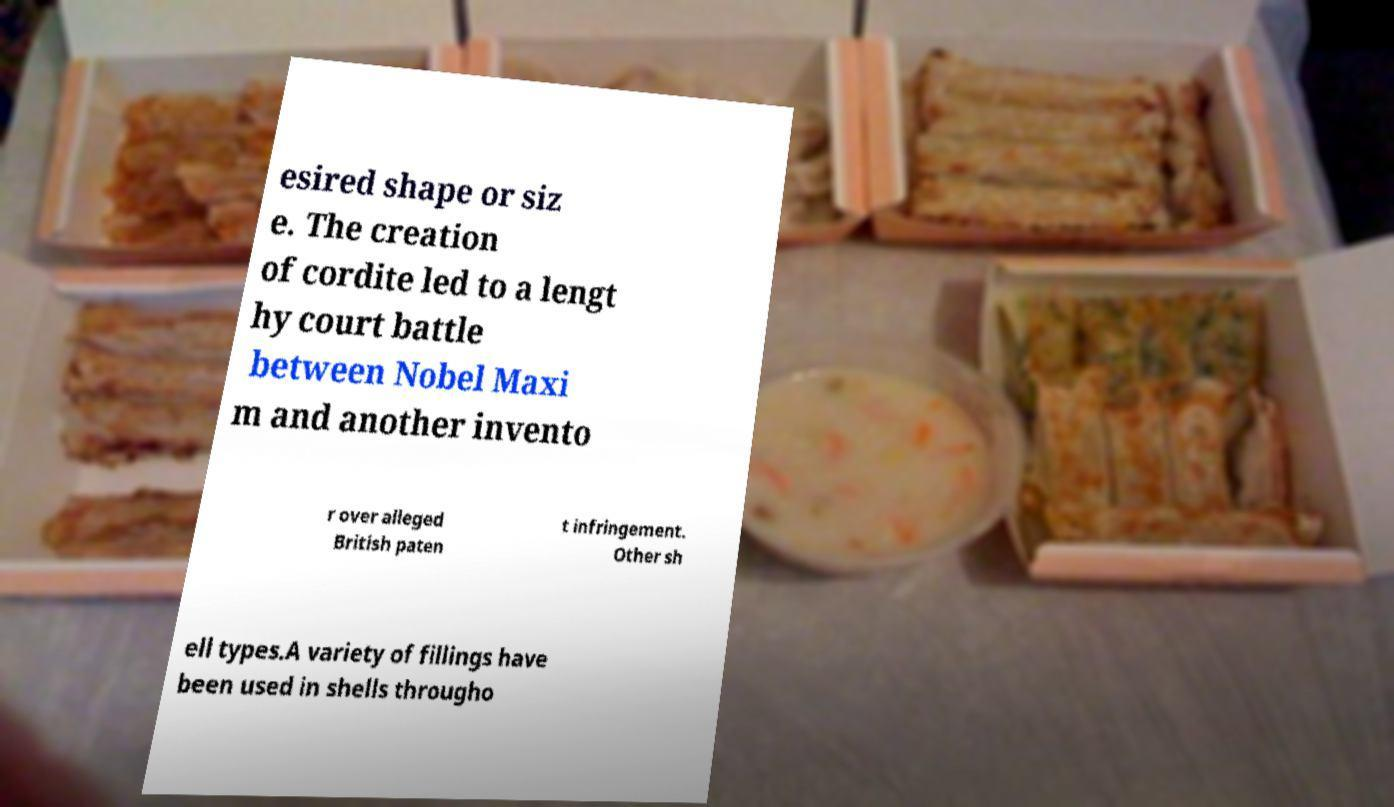Could you extract and type out the text from this image? esired shape or siz e. The creation of cordite led to a lengt hy court battle between Nobel Maxi m and another invento r over alleged British paten t infringement. Other sh ell types.A variety of fillings have been used in shells througho 